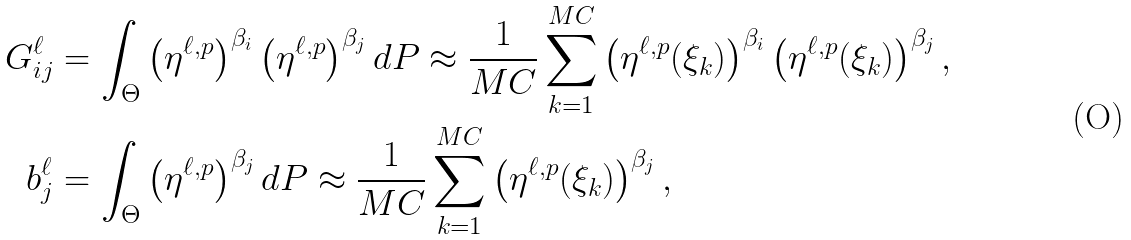<formula> <loc_0><loc_0><loc_500><loc_500>G _ { i j } ^ { \ell } & = \int _ { \Theta } \left ( \eta ^ { \ell , p } \right ) ^ { \beta _ { i } } \left ( \eta ^ { \ell , p } \right ) ^ { \beta _ { j } } d P \approx \frac { 1 } { M C } \sum _ { k = 1 } ^ { M C } \left ( \eta ^ { \ell , p } ( \xi _ { k } ) \right ) ^ { \beta _ { i } } \left ( \eta ^ { \ell , p } ( \xi _ { k } ) \right ) ^ { \beta _ { j } } , \\ b _ { j } ^ { \ell } & = \int _ { \Theta } \left ( \eta ^ { \ell , p } \right ) ^ { \beta _ { j } } d P \approx \frac { 1 } { M C } \sum _ { k = 1 } ^ { M C } \left ( \eta ^ { \ell , p } ( \xi _ { k } ) \right ) ^ { \beta _ { j } } ,</formula> 